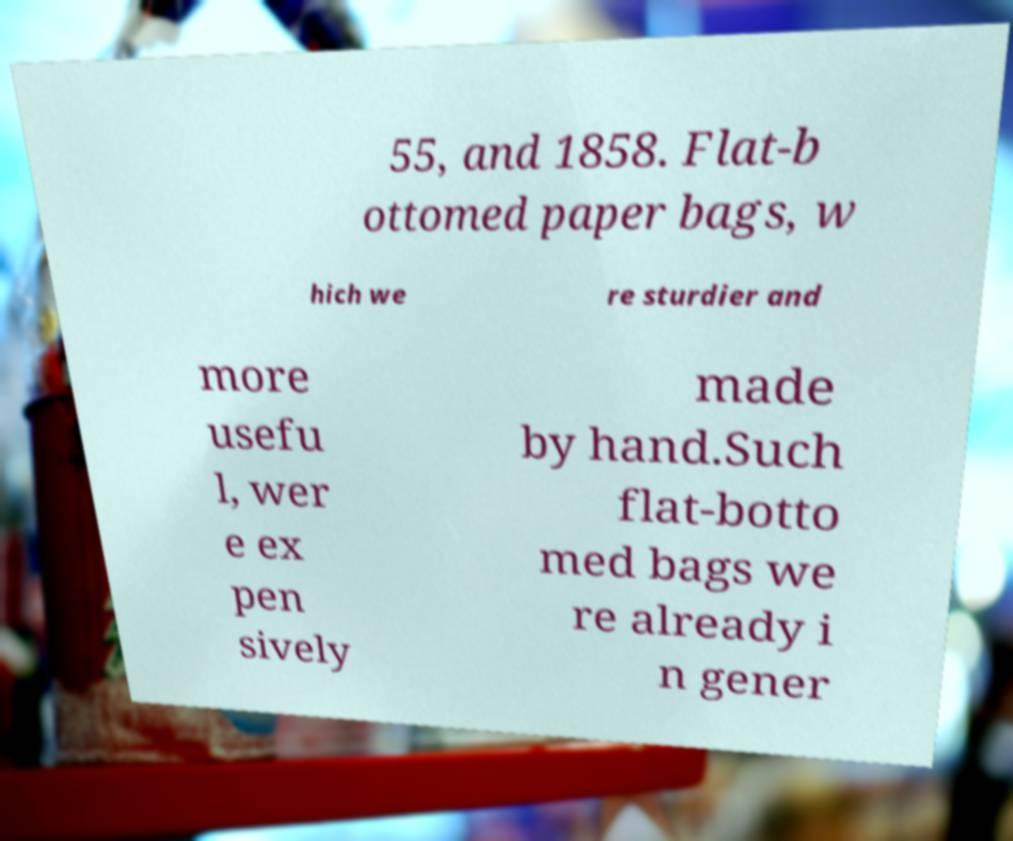For documentation purposes, I need the text within this image transcribed. Could you provide that? 55, and 1858. Flat-b ottomed paper bags, w hich we re sturdier and more usefu l, wer e ex pen sively made by hand.Such flat-botto med bags we re already i n gener 